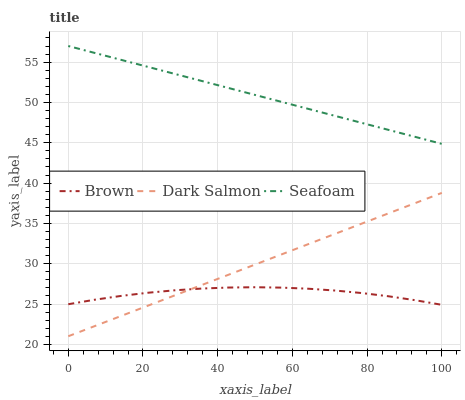Does Brown have the minimum area under the curve?
Answer yes or no. Yes. Does Seafoam have the maximum area under the curve?
Answer yes or no. Yes. Does Dark Salmon have the minimum area under the curve?
Answer yes or no. No. Does Dark Salmon have the maximum area under the curve?
Answer yes or no. No. Is Seafoam the smoothest?
Answer yes or no. Yes. Is Brown the roughest?
Answer yes or no. Yes. Is Dark Salmon the smoothest?
Answer yes or no. No. Is Dark Salmon the roughest?
Answer yes or no. No. Does Dark Salmon have the lowest value?
Answer yes or no. Yes. Does Seafoam have the lowest value?
Answer yes or no. No. Does Seafoam have the highest value?
Answer yes or no. Yes. Does Dark Salmon have the highest value?
Answer yes or no. No. Is Dark Salmon less than Seafoam?
Answer yes or no. Yes. Is Seafoam greater than Brown?
Answer yes or no. Yes. Does Dark Salmon intersect Brown?
Answer yes or no. Yes. Is Dark Salmon less than Brown?
Answer yes or no. No. Is Dark Salmon greater than Brown?
Answer yes or no. No. Does Dark Salmon intersect Seafoam?
Answer yes or no. No. 